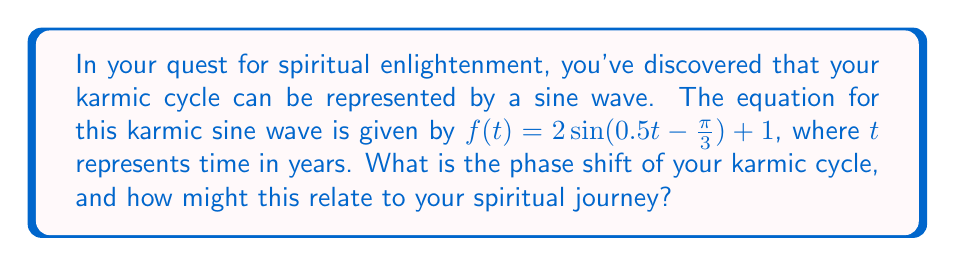Give your solution to this math problem. To find the phase shift of the karmic cycle represented by this sine wave, we need to analyze the given equation:

$f(t) = 2\sin(0.5t - \frac{\pi}{3}) + 1$

The general form of a sine function with phase shift is:

$f(t) = A\sin(B(t - C)) + D$

Where:
- $A$ is the amplitude
- $B$ is the frequency
- $C$ is the phase shift
- $D$ is the vertical shift

In our equation:
$f(t) = 2\sin(0.5t - \frac{\pi}{3}) + 1$

We need to rewrite it in the form $\sin(0.5(t - C))$:

$0.5t - \frac{\pi}{3} = 0.5(t - C)$

Solving for $C$:
$0.5t - \frac{\pi}{3} = 0.5t - 0.5C$
$-\frac{\pi}{3} = -0.5C$
$C = \frac{2\pi}{3}$

Therefore, the phase shift is $\frac{2\pi}{3}$ radians or $\frac{2\pi}{3} \cdot \frac{180°}{\pi} = 120°$.

In the context of your spiritual journey, this phase shift might represent the initial offset of your karmic cycle. It suggests that your spiritual path may have already progressed through one-third of a full cycle before the start of this particular measurement or observation.
Answer: The phase shift of the karmic cycle is $\frac{2\pi}{3}$ radians or 120°. 